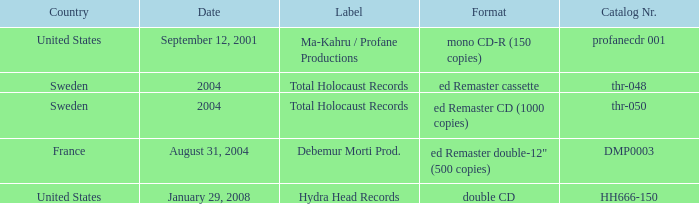Which country has the format ed Remaster double-12" (500 copies)? France. 